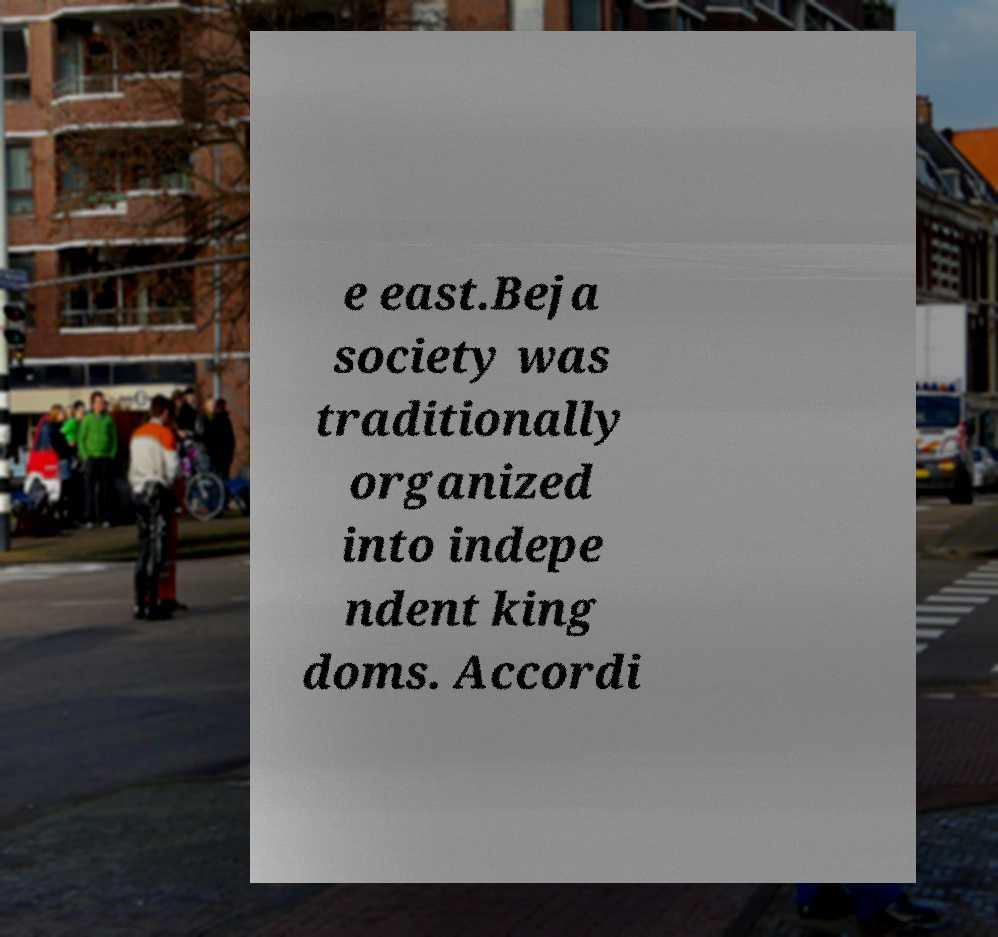I need the written content from this picture converted into text. Can you do that? e east.Beja society was traditionally organized into indepe ndent king doms. Accordi 